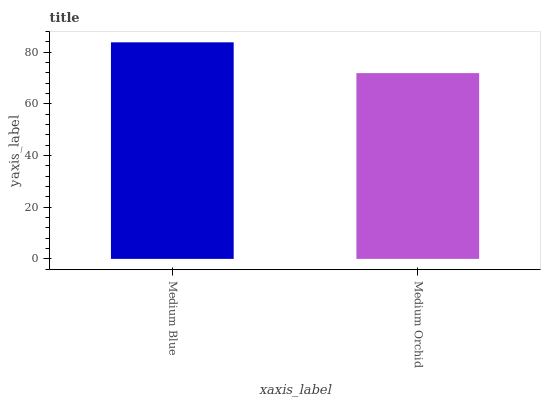Is Medium Orchid the minimum?
Answer yes or no. Yes. Is Medium Blue the maximum?
Answer yes or no. Yes. Is Medium Orchid the maximum?
Answer yes or no. No. Is Medium Blue greater than Medium Orchid?
Answer yes or no. Yes. Is Medium Orchid less than Medium Blue?
Answer yes or no. Yes. Is Medium Orchid greater than Medium Blue?
Answer yes or no. No. Is Medium Blue less than Medium Orchid?
Answer yes or no. No. Is Medium Blue the high median?
Answer yes or no. Yes. Is Medium Orchid the low median?
Answer yes or no. Yes. Is Medium Orchid the high median?
Answer yes or no. No. Is Medium Blue the low median?
Answer yes or no. No. 